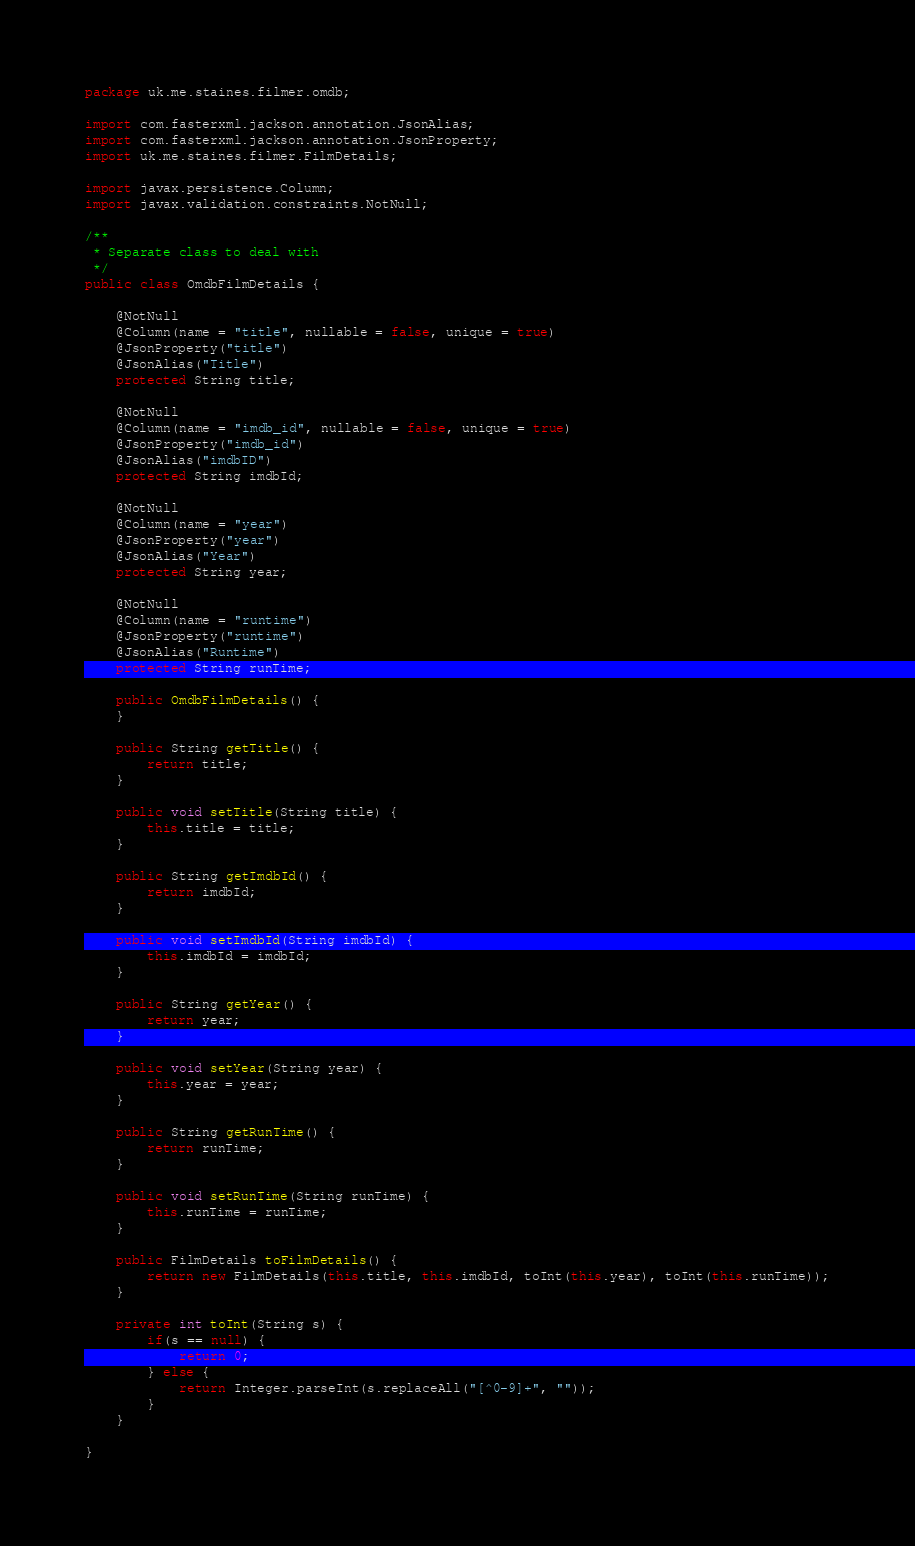<code> <loc_0><loc_0><loc_500><loc_500><_Java_>package uk.me.staines.filmer.omdb;

import com.fasterxml.jackson.annotation.JsonAlias;
import com.fasterxml.jackson.annotation.JsonProperty;
import uk.me.staines.filmer.FilmDetails;

import javax.persistence.Column;
import javax.validation.constraints.NotNull;

/**
 * Separate class to deal with
 */
public class OmdbFilmDetails {

    @NotNull
    @Column(name = "title", nullable = false, unique = true)
    @JsonProperty("title")
    @JsonAlias("Title")
    protected String title;

    @NotNull
    @Column(name = "imdb_id", nullable = false, unique = true)
    @JsonProperty("imdb_id")
    @JsonAlias("imdbID")
    protected String imdbId;

    @NotNull
    @Column(name = "year")
    @JsonProperty("year")
    @JsonAlias("Year")
    protected String year;

    @NotNull
    @Column(name = "runtime")
    @JsonProperty("runtime")
    @JsonAlias("Runtime")
    protected String runTime;

    public OmdbFilmDetails() {
    }

    public String getTitle() {
        return title;
    }

    public void setTitle(String title) {
        this.title = title;
    }

    public String getImdbId() {
        return imdbId;
    }

    public void setImdbId(String imdbId) {
        this.imdbId = imdbId;
    }

    public String getYear() {
        return year;
    }

    public void setYear(String year) {
        this.year = year;
    }

    public String getRunTime() {
        return runTime;
    }

    public void setRunTime(String runTime) {
        this.runTime = runTime;
    }

    public FilmDetails toFilmDetails() {
        return new FilmDetails(this.title, this.imdbId, toInt(this.year), toInt(this.runTime));
    }

    private int toInt(String s) {
        if(s == null) {
            return 0;
        } else {
            return Integer.parseInt(s.replaceAll("[^0-9]+", ""));
        }
    }

}
</code> 